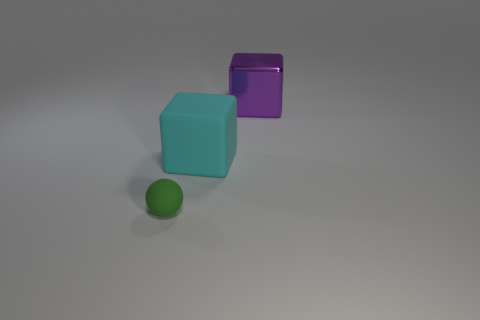Are there any other things that are the same material as the purple cube?
Provide a succinct answer. No. Are there any tiny matte things of the same color as the matte block?
Offer a terse response. No. What number of objects are either cyan balls or rubber things right of the tiny matte ball?
Provide a succinct answer. 1. Is the number of large purple metal objects greater than the number of gray metallic blocks?
Your answer should be very brief. Yes. Are there any red balls that have the same material as the big cyan cube?
Your answer should be compact. No. What is the shape of the thing that is to the left of the purple metallic thing and on the right side of the small green sphere?
Give a very brief answer. Cube. What number of other things are the same shape as the green thing?
Your answer should be compact. 0. The rubber sphere has what size?
Give a very brief answer. Small. How many things are either metallic things or large rubber things?
Provide a short and direct response. 2. There is a block left of the big purple block; what size is it?
Provide a succinct answer. Large. 